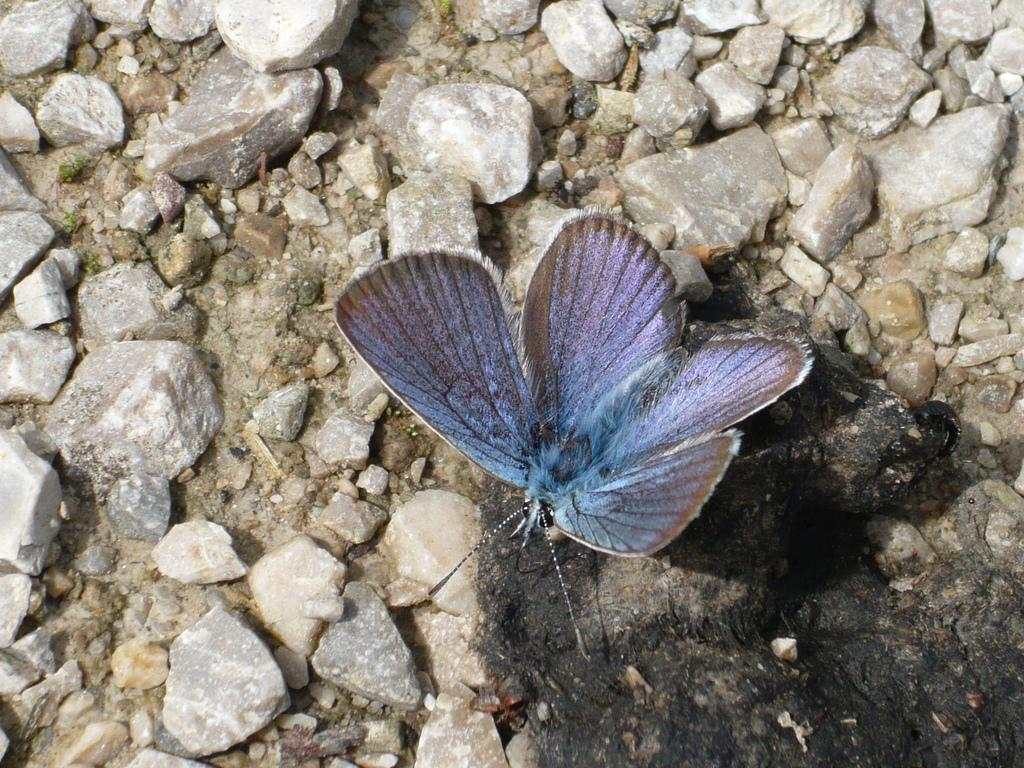What type of animal can be seen in the image? There is a butterfly in the image. What type of natural objects are present in the image? There are stones in the image. What level of difficulty is the butterfly designed for in the image? The image does not provide information about the difficulty level of the butterfly. What type of question is the butterfly answering in the image? The image does not depict the butterfly answering any questions. What type of list is the butterfly a part of in the image? The image does not depict the butterfly as a part of any list. 